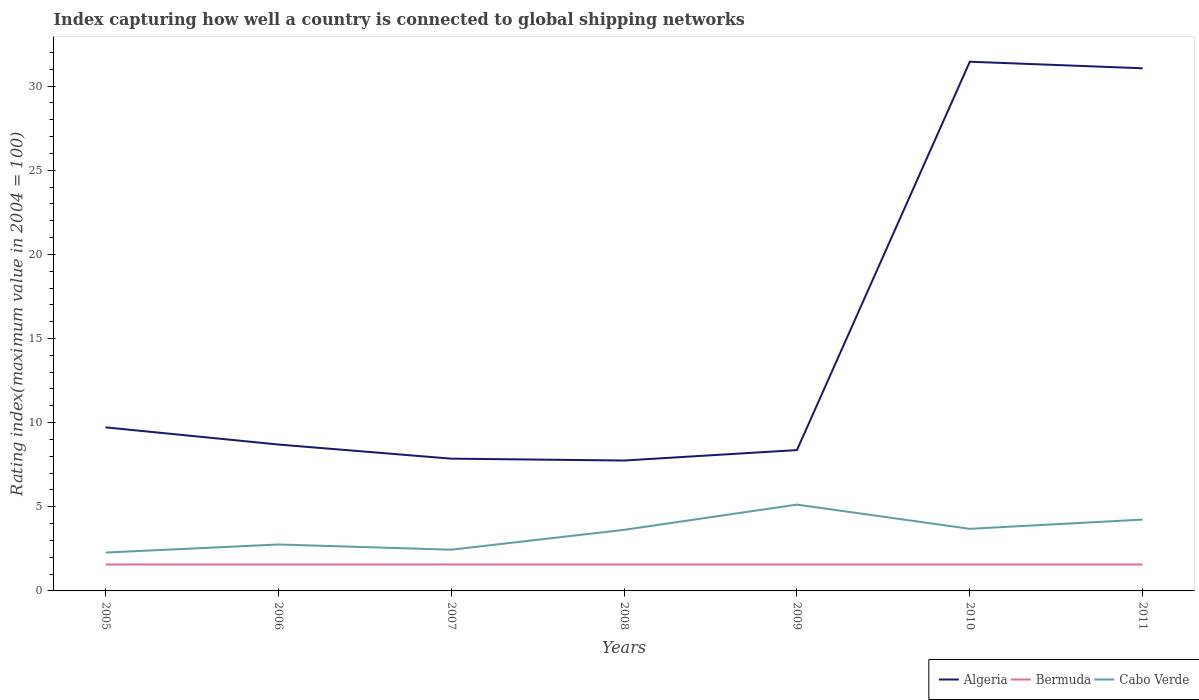How many different coloured lines are there?
Offer a terse response. 3. Does the line corresponding to Bermuda intersect with the line corresponding to Algeria?
Ensure brevity in your answer.  No. Is the number of lines equal to the number of legend labels?
Give a very brief answer. Yes. Across all years, what is the maximum rating index in Cabo Verde?
Give a very brief answer. 2.28. In which year was the rating index in Cabo Verde maximum?
Give a very brief answer. 2005. What is the total rating index in Bermuda in the graph?
Your answer should be very brief. 0. What is the difference between the highest and the second highest rating index in Algeria?
Provide a short and direct response. 23.7. How many lines are there?
Offer a terse response. 3. Are the values on the major ticks of Y-axis written in scientific E-notation?
Provide a succinct answer. No. Does the graph contain grids?
Provide a succinct answer. No. Where does the legend appear in the graph?
Offer a terse response. Bottom right. What is the title of the graph?
Provide a short and direct response. Index capturing how well a country is connected to global shipping networks. Does "Comoros" appear as one of the legend labels in the graph?
Keep it short and to the point. No. What is the label or title of the Y-axis?
Offer a very short reply. Rating index(maximum value in 2004 = 100). What is the Rating index(maximum value in 2004 = 100) in Algeria in 2005?
Keep it short and to the point. 9.72. What is the Rating index(maximum value in 2004 = 100) of Bermuda in 2005?
Your response must be concise. 1.57. What is the Rating index(maximum value in 2004 = 100) in Cabo Verde in 2005?
Make the answer very short. 2.28. What is the Rating index(maximum value in 2004 = 100) of Algeria in 2006?
Your response must be concise. 8.7. What is the Rating index(maximum value in 2004 = 100) in Bermuda in 2006?
Your answer should be compact. 1.57. What is the Rating index(maximum value in 2004 = 100) in Cabo Verde in 2006?
Your answer should be compact. 2.76. What is the Rating index(maximum value in 2004 = 100) in Algeria in 2007?
Offer a very short reply. 7.86. What is the Rating index(maximum value in 2004 = 100) in Bermuda in 2007?
Provide a short and direct response. 1.57. What is the Rating index(maximum value in 2004 = 100) in Cabo Verde in 2007?
Your answer should be compact. 2.45. What is the Rating index(maximum value in 2004 = 100) of Algeria in 2008?
Your answer should be compact. 7.75. What is the Rating index(maximum value in 2004 = 100) of Bermuda in 2008?
Offer a terse response. 1.57. What is the Rating index(maximum value in 2004 = 100) in Cabo Verde in 2008?
Keep it short and to the point. 3.63. What is the Rating index(maximum value in 2004 = 100) of Algeria in 2009?
Give a very brief answer. 8.37. What is the Rating index(maximum value in 2004 = 100) in Bermuda in 2009?
Offer a terse response. 1.57. What is the Rating index(maximum value in 2004 = 100) of Cabo Verde in 2009?
Make the answer very short. 5.13. What is the Rating index(maximum value in 2004 = 100) of Algeria in 2010?
Offer a very short reply. 31.45. What is the Rating index(maximum value in 2004 = 100) in Bermuda in 2010?
Make the answer very short. 1.57. What is the Rating index(maximum value in 2004 = 100) in Cabo Verde in 2010?
Keep it short and to the point. 3.69. What is the Rating index(maximum value in 2004 = 100) of Algeria in 2011?
Give a very brief answer. 31.06. What is the Rating index(maximum value in 2004 = 100) of Bermuda in 2011?
Offer a terse response. 1.57. What is the Rating index(maximum value in 2004 = 100) in Cabo Verde in 2011?
Make the answer very short. 4.24. Across all years, what is the maximum Rating index(maximum value in 2004 = 100) of Algeria?
Offer a very short reply. 31.45. Across all years, what is the maximum Rating index(maximum value in 2004 = 100) of Bermuda?
Offer a terse response. 1.57. Across all years, what is the maximum Rating index(maximum value in 2004 = 100) in Cabo Verde?
Ensure brevity in your answer.  5.13. Across all years, what is the minimum Rating index(maximum value in 2004 = 100) in Algeria?
Your response must be concise. 7.75. Across all years, what is the minimum Rating index(maximum value in 2004 = 100) in Bermuda?
Offer a very short reply. 1.57. Across all years, what is the minimum Rating index(maximum value in 2004 = 100) in Cabo Verde?
Your answer should be very brief. 2.28. What is the total Rating index(maximum value in 2004 = 100) in Algeria in the graph?
Keep it short and to the point. 104.91. What is the total Rating index(maximum value in 2004 = 100) in Bermuda in the graph?
Your response must be concise. 10.99. What is the total Rating index(maximum value in 2004 = 100) in Cabo Verde in the graph?
Your answer should be compact. 24.18. What is the difference between the Rating index(maximum value in 2004 = 100) of Cabo Verde in 2005 and that in 2006?
Offer a terse response. -0.48. What is the difference between the Rating index(maximum value in 2004 = 100) in Algeria in 2005 and that in 2007?
Offer a terse response. 1.86. What is the difference between the Rating index(maximum value in 2004 = 100) in Cabo Verde in 2005 and that in 2007?
Provide a succinct answer. -0.17. What is the difference between the Rating index(maximum value in 2004 = 100) in Algeria in 2005 and that in 2008?
Keep it short and to the point. 1.97. What is the difference between the Rating index(maximum value in 2004 = 100) in Cabo Verde in 2005 and that in 2008?
Your answer should be compact. -1.35. What is the difference between the Rating index(maximum value in 2004 = 100) in Algeria in 2005 and that in 2009?
Offer a terse response. 1.35. What is the difference between the Rating index(maximum value in 2004 = 100) of Cabo Verde in 2005 and that in 2009?
Keep it short and to the point. -2.85. What is the difference between the Rating index(maximum value in 2004 = 100) of Algeria in 2005 and that in 2010?
Offer a terse response. -21.73. What is the difference between the Rating index(maximum value in 2004 = 100) of Cabo Verde in 2005 and that in 2010?
Offer a very short reply. -1.41. What is the difference between the Rating index(maximum value in 2004 = 100) in Algeria in 2005 and that in 2011?
Your answer should be compact. -21.34. What is the difference between the Rating index(maximum value in 2004 = 100) of Bermuda in 2005 and that in 2011?
Give a very brief answer. 0. What is the difference between the Rating index(maximum value in 2004 = 100) of Cabo Verde in 2005 and that in 2011?
Your response must be concise. -1.96. What is the difference between the Rating index(maximum value in 2004 = 100) of Algeria in 2006 and that in 2007?
Keep it short and to the point. 0.84. What is the difference between the Rating index(maximum value in 2004 = 100) of Cabo Verde in 2006 and that in 2007?
Make the answer very short. 0.31. What is the difference between the Rating index(maximum value in 2004 = 100) in Bermuda in 2006 and that in 2008?
Your response must be concise. 0. What is the difference between the Rating index(maximum value in 2004 = 100) of Cabo Verde in 2006 and that in 2008?
Provide a succinct answer. -0.87. What is the difference between the Rating index(maximum value in 2004 = 100) of Algeria in 2006 and that in 2009?
Your response must be concise. 0.33. What is the difference between the Rating index(maximum value in 2004 = 100) of Bermuda in 2006 and that in 2009?
Offer a very short reply. 0. What is the difference between the Rating index(maximum value in 2004 = 100) of Cabo Verde in 2006 and that in 2009?
Offer a terse response. -2.37. What is the difference between the Rating index(maximum value in 2004 = 100) of Algeria in 2006 and that in 2010?
Offer a very short reply. -22.75. What is the difference between the Rating index(maximum value in 2004 = 100) in Bermuda in 2006 and that in 2010?
Ensure brevity in your answer.  0. What is the difference between the Rating index(maximum value in 2004 = 100) of Cabo Verde in 2006 and that in 2010?
Give a very brief answer. -0.93. What is the difference between the Rating index(maximum value in 2004 = 100) of Algeria in 2006 and that in 2011?
Make the answer very short. -22.36. What is the difference between the Rating index(maximum value in 2004 = 100) of Cabo Verde in 2006 and that in 2011?
Your answer should be compact. -1.48. What is the difference between the Rating index(maximum value in 2004 = 100) of Algeria in 2007 and that in 2008?
Make the answer very short. 0.11. What is the difference between the Rating index(maximum value in 2004 = 100) of Bermuda in 2007 and that in 2008?
Offer a very short reply. 0. What is the difference between the Rating index(maximum value in 2004 = 100) in Cabo Verde in 2007 and that in 2008?
Offer a terse response. -1.18. What is the difference between the Rating index(maximum value in 2004 = 100) in Algeria in 2007 and that in 2009?
Offer a terse response. -0.51. What is the difference between the Rating index(maximum value in 2004 = 100) in Cabo Verde in 2007 and that in 2009?
Provide a succinct answer. -2.68. What is the difference between the Rating index(maximum value in 2004 = 100) of Algeria in 2007 and that in 2010?
Provide a succinct answer. -23.59. What is the difference between the Rating index(maximum value in 2004 = 100) in Cabo Verde in 2007 and that in 2010?
Your response must be concise. -1.24. What is the difference between the Rating index(maximum value in 2004 = 100) of Algeria in 2007 and that in 2011?
Provide a short and direct response. -23.2. What is the difference between the Rating index(maximum value in 2004 = 100) of Cabo Verde in 2007 and that in 2011?
Keep it short and to the point. -1.79. What is the difference between the Rating index(maximum value in 2004 = 100) of Algeria in 2008 and that in 2009?
Your answer should be compact. -0.62. What is the difference between the Rating index(maximum value in 2004 = 100) in Bermuda in 2008 and that in 2009?
Your answer should be compact. 0. What is the difference between the Rating index(maximum value in 2004 = 100) of Algeria in 2008 and that in 2010?
Give a very brief answer. -23.7. What is the difference between the Rating index(maximum value in 2004 = 100) in Bermuda in 2008 and that in 2010?
Provide a succinct answer. 0. What is the difference between the Rating index(maximum value in 2004 = 100) of Cabo Verde in 2008 and that in 2010?
Offer a very short reply. -0.06. What is the difference between the Rating index(maximum value in 2004 = 100) in Algeria in 2008 and that in 2011?
Provide a succinct answer. -23.31. What is the difference between the Rating index(maximum value in 2004 = 100) in Cabo Verde in 2008 and that in 2011?
Offer a very short reply. -0.61. What is the difference between the Rating index(maximum value in 2004 = 100) of Algeria in 2009 and that in 2010?
Offer a terse response. -23.08. What is the difference between the Rating index(maximum value in 2004 = 100) in Cabo Verde in 2009 and that in 2010?
Your answer should be compact. 1.44. What is the difference between the Rating index(maximum value in 2004 = 100) of Algeria in 2009 and that in 2011?
Provide a short and direct response. -22.69. What is the difference between the Rating index(maximum value in 2004 = 100) of Bermuda in 2009 and that in 2011?
Provide a short and direct response. 0. What is the difference between the Rating index(maximum value in 2004 = 100) in Cabo Verde in 2009 and that in 2011?
Your answer should be very brief. 0.89. What is the difference between the Rating index(maximum value in 2004 = 100) of Algeria in 2010 and that in 2011?
Ensure brevity in your answer.  0.39. What is the difference between the Rating index(maximum value in 2004 = 100) of Cabo Verde in 2010 and that in 2011?
Give a very brief answer. -0.55. What is the difference between the Rating index(maximum value in 2004 = 100) in Algeria in 2005 and the Rating index(maximum value in 2004 = 100) in Bermuda in 2006?
Give a very brief answer. 8.15. What is the difference between the Rating index(maximum value in 2004 = 100) of Algeria in 2005 and the Rating index(maximum value in 2004 = 100) of Cabo Verde in 2006?
Provide a succinct answer. 6.96. What is the difference between the Rating index(maximum value in 2004 = 100) of Bermuda in 2005 and the Rating index(maximum value in 2004 = 100) of Cabo Verde in 2006?
Ensure brevity in your answer.  -1.19. What is the difference between the Rating index(maximum value in 2004 = 100) of Algeria in 2005 and the Rating index(maximum value in 2004 = 100) of Bermuda in 2007?
Give a very brief answer. 8.15. What is the difference between the Rating index(maximum value in 2004 = 100) in Algeria in 2005 and the Rating index(maximum value in 2004 = 100) in Cabo Verde in 2007?
Your answer should be very brief. 7.27. What is the difference between the Rating index(maximum value in 2004 = 100) in Bermuda in 2005 and the Rating index(maximum value in 2004 = 100) in Cabo Verde in 2007?
Your answer should be compact. -0.88. What is the difference between the Rating index(maximum value in 2004 = 100) of Algeria in 2005 and the Rating index(maximum value in 2004 = 100) of Bermuda in 2008?
Ensure brevity in your answer.  8.15. What is the difference between the Rating index(maximum value in 2004 = 100) of Algeria in 2005 and the Rating index(maximum value in 2004 = 100) of Cabo Verde in 2008?
Your answer should be compact. 6.09. What is the difference between the Rating index(maximum value in 2004 = 100) in Bermuda in 2005 and the Rating index(maximum value in 2004 = 100) in Cabo Verde in 2008?
Your answer should be very brief. -2.06. What is the difference between the Rating index(maximum value in 2004 = 100) of Algeria in 2005 and the Rating index(maximum value in 2004 = 100) of Bermuda in 2009?
Offer a terse response. 8.15. What is the difference between the Rating index(maximum value in 2004 = 100) in Algeria in 2005 and the Rating index(maximum value in 2004 = 100) in Cabo Verde in 2009?
Provide a succinct answer. 4.59. What is the difference between the Rating index(maximum value in 2004 = 100) of Bermuda in 2005 and the Rating index(maximum value in 2004 = 100) of Cabo Verde in 2009?
Your response must be concise. -3.56. What is the difference between the Rating index(maximum value in 2004 = 100) of Algeria in 2005 and the Rating index(maximum value in 2004 = 100) of Bermuda in 2010?
Your response must be concise. 8.15. What is the difference between the Rating index(maximum value in 2004 = 100) of Algeria in 2005 and the Rating index(maximum value in 2004 = 100) of Cabo Verde in 2010?
Provide a short and direct response. 6.03. What is the difference between the Rating index(maximum value in 2004 = 100) of Bermuda in 2005 and the Rating index(maximum value in 2004 = 100) of Cabo Verde in 2010?
Make the answer very short. -2.12. What is the difference between the Rating index(maximum value in 2004 = 100) in Algeria in 2005 and the Rating index(maximum value in 2004 = 100) in Bermuda in 2011?
Ensure brevity in your answer.  8.15. What is the difference between the Rating index(maximum value in 2004 = 100) of Algeria in 2005 and the Rating index(maximum value in 2004 = 100) of Cabo Verde in 2011?
Provide a short and direct response. 5.48. What is the difference between the Rating index(maximum value in 2004 = 100) of Bermuda in 2005 and the Rating index(maximum value in 2004 = 100) of Cabo Verde in 2011?
Provide a short and direct response. -2.67. What is the difference between the Rating index(maximum value in 2004 = 100) of Algeria in 2006 and the Rating index(maximum value in 2004 = 100) of Bermuda in 2007?
Provide a short and direct response. 7.13. What is the difference between the Rating index(maximum value in 2004 = 100) of Algeria in 2006 and the Rating index(maximum value in 2004 = 100) of Cabo Verde in 2007?
Provide a succinct answer. 6.25. What is the difference between the Rating index(maximum value in 2004 = 100) in Bermuda in 2006 and the Rating index(maximum value in 2004 = 100) in Cabo Verde in 2007?
Your answer should be compact. -0.88. What is the difference between the Rating index(maximum value in 2004 = 100) of Algeria in 2006 and the Rating index(maximum value in 2004 = 100) of Bermuda in 2008?
Your response must be concise. 7.13. What is the difference between the Rating index(maximum value in 2004 = 100) in Algeria in 2006 and the Rating index(maximum value in 2004 = 100) in Cabo Verde in 2008?
Your response must be concise. 5.07. What is the difference between the Rating index(maximum value in 2004 = 100) of Bermuda in 2006 and the Rating index(maximum value in 2004 = 100) of Cabo Verde in 2008?
Your answer should be very brief. -2.06. What is the difference between the Rating index(maximum value in 2004 = 100) of Algeria in 2006 and the Rating index(maximum value in 2004 = 100) of Bermuda in 2009?
Provide a succinct answer. 7.13. What is the difference between the Rating index(maximum value in 2004 = 100) of Algeria in 2006 and the Rating index(maximum value in 2004 = 100) of Cabo Verde in 2009?
Make the answer very short. 3.57. What is the difference between the Rating index(maximum value in 2004 = 100) in Bermuda in 2006 and the Rating index(maximum value in 2004 = 100) in Cabo Verde in 2009?
Your answer should be compact. -3.56. What is the difference between the Rating index(maximum value in 2004 = 100) in Algeria in 2006 and the Rating index(maximum value in 2004 = 100) in Bermuda in 2010?
Ensure brevity in your answer.  7.13. What is the difference between the Rating index(maximum value in 2004 = 100) in Algeria in 2006 and the Rating index(maximum value in 2004 = 100) in Cabo Verde in 2010?
Offer a very short reply. 5.01. What is the difference between the Rating index(maximum value in 2004 = 100) of Bermuda in 2006 and the Rating index(maximum value in 2004 = 100) of Cabo Verde in 2010?
Offer a very short reply. -2.12. What is the difference between the Rating index(maximum value in 2004 = 100) in Algeria in 2006 and the Rating index(maximum value in 2004 = 100) in Bermuda in 2011?
Provide a short and direct response. 7.13. What is the difference between the Rating index(maximum value in 2004 = 100) in Algeria in 2006 and the Rating index(maximum value in 2004 = 100) in Cabo Verde in 2011?
Offer a very short reply. 4.46. What is the difference between the Rating index(maximum value in 2004 = 100) in Bermuda in 2006 and the Rating index(maximum value in 2004 = 100) in Cabo Verde in 2011?
Provide a short and direct response. -2.67. What is the difference between the Rating index(maximum value in 2004 = 100) in Algeria in 2007 and the Rating index(maximum value in 2004 = 100) in Bermuda in 2008?
Offer a terse response. 6.29. What is the difference between the Rating index(maximum value in 2004 = 100) of Algeria in 2007 and the Rating index(maximum value in 2004 = 100) of Cabo Verde in 2008?
Make the answer very short. 4.23. What is the difference between the Rating index(maximum value in 2004 = 100) of Bermuda in 2007 and the Rating index(maximum value in 2004 = 100) of Cabo Verde in 2008?
Your answer should be very brief. -2.06. What is the difference between the Rating index(maximum value in 2004 = 100) in Algeria in 2007 and the Rating index(maximum value in 2004 = 100) in Bermuda in 2009?
Offer a very short reply. 6.29. What is the difference between the Rating index(maximum value in 2004 = 100) of Algeria in 2007 and the Rating index(maximum value in 2004 = 100) of Cabo Verde in 2009?
Ensure brevity in your answer.  2.73. What is the difference between the Rating index(maximum value in 2004 = 100) in Bermuda in 2007 and the Rating index(maximum value in 2004 = 100) in Cabo Verde in 2009?
Give a very brief answer. -3.56. What is the difference between the Rating index(maximum value in 2004 = 100) of Algeria in 2007 and the Rating index(maximum value in 2004 = 100) of Bermuda in 2010?
Keep it short and to the point. 6.29. What is the difference between the Rating index(maximum value in 2004 = 100) of Algeria in 2007 and the Rating index(maximum value in 2004 = 100) of Cabo Verde in 2010?
Your answer should be compact. 4.17. What is the difference between the Rating index(maximum value in 2004 = 100) in Bermuda in 2007 and the Rating index(maximum value in 2004 = 100) in Cabo Verde in 2010?
Your answer should be very brief. -2.12. What is the difference between the Rating index(maximum value in 2004 = 100) of Algeria in 2007 and the Rating index(maximum value in 2004 = 100) of Bermuda in 2011?
Your answer should be very brief. 6.29. What is the difference between the Rating index(maximum value in 2004 = 100) of Algeria in 2007 and the Rating index(maximum value in 2004 = 100) of Cabo Verde in 2011?
Provide a short and direct response. 3.62. What is the difference between the Rating index(maximum value in 2004 = 100) of Bermuda in 2007 and the Rating index(maximum value in 2004 = 100) of Cabo Verde in 2011?
Your answer should be compact. -2.67. What is the difference between the Rating index(maximum value in 2004 = 100) of Algeria in 2008 and the Rating index(maximum value in 2004 = 100) of Bermuda in 2009?
Make the answer very short. 6.18. What is the difference between the Rating index(maximum value in 2004 = 100) in Algeria in 2008 and the Rating index(maximum value in 2004 = 100) in Cabo Verde in 2009?
Provide a succinct answer. 2.62. What is the difference between the Rating index(maximum value in 2004 = 100) of Bermuda in 2008 and the Rating index(maximum value in 2004 = 100) of Cabo Verde in 2009?
Your answer should be very brief. -3.56. What is the difference between the Rating index(maximum value in 2004 = 100) in Algeria in 2008 and the Rating index(maximum value in 2004 = 100) in Bermuda in 2010?
Offer a terse response. 6.18. What is the difference between the Rating index(maximum value in 2004 = 100) in Algeria in 2008 and the Rating index(maximum value in 2004 = 100) in Cabo Verde in 2010?
Offer a very short reply. 4.06. What is the difference between the Rating index(maximum value in 2004 = 100) of Bermuda in 2008 and the Rating index(maximum value in 2004 = 100) of Cabo Verde in 2010?
Your answer should be very brief. -2.12. What is the difference between the Rating index(maximum value in 2004 = 100) in Algeria in 2008 and the Rating index(maximum value in 2004 = 100) in Bermuda in 2011?
Your response must be concise. 6.18. What is the difference between the Rating index(maximum value in 2004 = 100) in Algeria in 2008 and the Rating index(maximum value in 2004 = 100) in Cabo Verde in 2011?
Ensure brevity in your answer.  3.51. What is the difference between the Rating index(maximum value in 2004 = 100) in Bermuda in 2008 and the Rating index(maximum value in 2004 = 100) in Cabo Verde in 2011?
Provide a short and direct response. -2.67. What is the difference between the Rating index(maximum value in 2004 = 100) in Algeria in 2009 and the Rating index(maximum value in 2004 = 100) in Cabo Verde in 2010?
Your answer should be very brief. 4.68. What is the difference between the Rating index(maximum value in 2004 = 100) of Bermuda in 2009 and the Rating index(maximum value in 2004 = 100) of Cabo Verde in 2010?
Provide a succinct answer. -2.12. What is the difference between the Rating index(maximum value in 2004 = 100) of Algeria in 2009 and the Rating index(maximum value in 2004 = 100) of Bermuda in 2011?
Your answer should be compact. 6.8. What is the difference between the Rating index(maximum value in 2004 = 100) in Algeria in 2009 and the Rating index(maximum value in 2004 = 100) in Cabo Verde in 2011?
Your response must be concise. 4.13. What is the difference between the Rating index(maximum value in 2004 = 100) in Bermuda in 2009 and the Rating index(maximum value in 2004 = 100) in Cabo Verde in 2011?
Ensure brevity in your answer.  -2.67. What is the difference between the Rating index(maximum value in 2004 = 100) of Algeria in 2010 and the Rating index(maximum value in 2004 = 100) of Bermuda in 2011?
Provide a succinct answer. 29.88. What is the difference between the Rating index(maximum value in 2004 = 100) in Algeria in 2010 and the Rating index(maximum value in 2004 = 100) in Cabo Verde in 2011?
Keep it short and to the point. 27.21. What is the difference between the Rating index(maximum value in 2004 = 100) of Bermuda in 2010 and the Rating index(maximum value in 2004 = 100) of Cabo Verde in 2011?
Provide a short and direct response. -2.67. What is the average Rating index(maximum value in 2004 = 100) of Algeria per year?
Your response must be concise. 14.99. What is the average Rating index(maximum value in 2004 = 100) of Bermuda per year?
Give a very brief answer. 1.57. What is the average Rating index(maximum value in 2004 = 100) of Cabo Verde per year?
Your answer should be compact. 3.45. In the year 2005, what is the difference between the Rating index(maximum value in 2004 = 100) of Algeria and Rating index(maximum value in 2004 = 100) of Bermuda?
Your answer should be very brief. 8.15. In the year 2005, what is the difference between the Rating index(maximum value in 2004 = 100) in Algeria and Rating index(maximum value in 2004 = 100) in Cabo Verde?
Offer a terse response. 7.44. In the year 2005, what is the difference between the Rating index(maximum value in 2004 = 100) in Bermuda and Rating index(maximum value in 2004 = 100) in Cabo Verde?
Make the answer very short. -0.71. In the year 2006, what is the difference between the Rating index(maximum value in 2004 = 100) of Algeria and Rating index(maximum value in 2004 = 100) of Bermuda?
Make the answer very short. 7.13. In the year 2006, what is the difference between the Rating index(maximum value in 2004 = 100) in Algeria and Rating index(maximum value in 2004 = 100) in Cabo Verde?
Offer a terse response. 5.94. In the year 2006, what is the difference between the Rating index(maximum value in 2004 = 100) of Bermuda and Rating index(maximum value in 2004 = 100) of Cabo Verde?
Give a very brief answer. -1.19. In the year 2007, what is the difference between the Rating index(maximum value in 2004 = 100) of Algeria and Rating index(maximum value in 2004 = 100) of Bermuda?
Provide a succinct answer. 6.29. In the year 2007, what is the difference between the Rating index(maximum value in 2004 = 100) in Algeria and Rating index(maximum value in 2004 = 100) in Cabo Verde?
Keep it short and to the point. 5.41. In the year 2007, what is the difference between the Rating index(maximum value in 2004 = 100) of Bermuda and Rating index(maximum value in 2004 = 100) of Cabo Verde?
Your answer should be very brief. -0.88. In the year 2008, what is the difference between the Rating index(maximum value in 2004 = 100) in Algeria and Rating index(maximum value in 2004 = 100) in Bermuda?
Keep it short and to the point. 6.18. In the year 2008, what is the difference between the Rating index(maximum value in 2004 = 100) in Algeria and Rating index(maximum value in 2004 = 100) in Cabo Verde?
Provide a short and direct response. 4.12. In the year 2008, what is the difference between the Rating index(maximum value in 2004 = 100) of Bermuda and Rating index(maximum value in 2004 = 100) of Cabo Verde?
Your response must be concise. -2.06. In the year 2009, what is the difference between the Rating index(maximum value in 2004 = 100) of Algeria and Rating index(maximum value in 2004 = 100) of Cabo Verde?
Provide a short and direct response. 3.24. In the year 2009, what is the difference between the Rating index(maximum value in 2004 = 100) in Bermuda and Rating index(maximum value in 2004 = 100) in Cabo Verde?
Give a very brief answer. -3.56. In the year 2010, what is the difference between the Rating index(maximum value in 2004 = 100) of Algeria and Rating index(maximum value in 2004 = 100) of Bermuda?
Your answer should be compact. 29.88. In the year 2010, what is the difference between the Rating index(maximum value in 2004 = 100) of Algeria and Rating index(maximum value in 2004 = 100) of Cabo Verde?
Offer a very short reply. 27.76. In the year 2010, what is the difference between the Rating index(maximum value in 2004 = 100) of Bermuda and Rating index(maximum value in 2004 = 100) of Cabo Verde?
Your response must be concise. -2.12. In the year 2011, what is the difference between the Rating index(maximum value in 2004 = 100) in Algeria and Rating index(maximum value in 2004 = 100) in Bermuda?
Provide a succinct answer. 29.49. In the year 2011, what is the difference between the Rating index(maximum value in 2004 = 100) of Algeria and Rating index(maximum value in 2004 = 100) of Cabo Verde?
Offer a terse response. 26.82. In the year 2011, what is the difference between the Rating index(maximum value in 2004 = 100) of Bermuda and Rating index(maximum value in 2004 = 100) of Cabo Verde?
Your answer should be compact. -2.67. What is the ratio of the Rating index(maximum value in 2004 = 100) of Algeria in 2005 to that in 2006?
Ensure brevity in your answer.  1.12. What is the ratio of the Rating index(maximum value in 2004 = 100) in Bermuda in 2005 to that in 2006?
Your answer should be compact. 1. What is the ratio of the Rating index(maximum value in 2004 = 100) of Cabo Verde in 2005 to that in 2006?
Provide a succinct answer. 0.83. What is the ratio of the Rating index(maximum value in 2004 = 100) of Algeria in 2005 to that in 2007?
Provide a short and direct response. 1.24. What is the ratio of the Rating index(maximum value in 2004 = 100) of Cabo Verde in 2005 to that in 2007?
Give a very brief answer. 0.93. What is the ratio of the Rating index(maximum value in 2004 = 100) of Algeria in 2005 to that in 2008?
Offer a terse response. 1.25. What is the ratio of the Rating index(maximum value in 2004 = 100) of Bermuda in 2005 to that in 2008?
Make the answer very short. 1. What is the ratio of the Rating index(maximum value in 2004 = 100) in Cabo Verde in 2005 to that in 2008?
Your response must be concise. 0.63. What is the ratio of the Rating index(maximum value in 2004 = 100) of Algeria in 2005 to that in 2009?
Give a very brief answer. 1.16. What is the ratio of the Rating index(maximum value in 2004 = 100) of Cabo Verde in 2005 to that in 2009?
Provide a succinct answer. 0.44. What is the ratio of the Rating index(maximum value in 2004 = 100) of Algeria in 2005 to that in 2010?
Keep it short and to the point. 0.31. What is the ratio of the Rating index(maximum value in 2004 = 100) in Cabo Verde in 2005 to that in 2010?
Give a very brief answer. 0.62. What is the ratio of the Rating index(maximum value in 2004 = 100) in Algeria in 2005 to that in 2011?
Provide a succinct answer. 0.31. What is the ratio of the Rating index(maximum value in 2004 = 100) in Cabo Verde in 2005 to that in 2011?
Ensure brevity in your answer.  0.54. What is the ratio of the Rating index(maximum value in 2004 = 100) of Algeria in 2006 to that in 2007?
Ensure brevity in your answer.  1.11. What is the ratio of the Rating index(maximum value in 2004 = 100) in Bermuda in 2006 to that in 2007?
Offer a very short reply. 1. What is the ratio of the Rating index(maximum value in 2004 = 100) of Cabo Verde in 2006 to that in 2007?
Provide a short and direct response. 1.13. What is the ratio of the Rating index(maximum value in 2004 = 100) of Algeria in 2006 to that in 2008?
Your answer should be compact. 1.12. What is the ratio of the Rating index(maximum value in 2004 = 100) of Cabo Verde in 2006 to that in 2008?
Make the answer very short. 0.76. What is the ratio of the Rating index(maximum value in 2004 = 100) in Algeria in 2006 to that in 2009?
Your answer should be compact. 1.04. What is the ratio of the Rating index(maximum value in 2004 = 100) of Cabo Verde in 2006 to that in 2009?
Your response must be concise. 0.54. What is the ratio of the Rating index(maximum value in 2004 = 100) in Algeria in 2006 to that in 2010?
Provide a succinct answer. 0.28. What is the ratio of the Rating index(maximum value in 2004 = 100) of Cabo Verde in 2006 to that in 2010?
Provide a short and direct response. 0.75. What is the ratio of the Rating index(maximum value in 2004 = 100) of Algeria in 2006 to that in 2011?
Keep it short and to the point. 0.28. What is the ratio of the Rating index(maximum value in 2004 = 100) of Bermuda in 2006 to that in 2011?
Your response must be concise. 1. What is the ratio of the Rating index(maximum value in 2004 = 100) in Cabo Verde in 2006 to that in 2011?
Ensure brevity in your answer.  0.65. What is the ratio of the Rating index(maximum value in 2004 = 100) of Algeria in 2007 to that in 2008?
Offer a very short reply. 1.01. What is the ratio of the Rating index(maximum value in 2004 = 100) of Cabo Verde in 2007 to that in 2008?
Provide a succinct answer. 0.67. What is the ratio of the Rating index(maximum value in 2004 = 100) in Algeria in 2007 to that in 2009?
Provide a succinct answer. 0.94. What is the ratio of the Rating index(maximum value in 2004 = 100) in Bermuda in 2007 to that in 2009?
Offer a very short reply. 1. What is the ratio of the Rating index(maximum value in 2004 = 100) in Cabo Verde in 2007 to that in 2009?
Your answer should be compact. 0.48. What is the ratio of the Rating index(maximum value in 2004 = 100) in Algeria in 2007 to that in 2010?
Your response must be concise. 0.25. What is the ratio of the Rating index(maximum value in 2004 = 100) of Cabo Verde in 2007 to that in 2010?
Your answer should be very brief. 0.66. What is the ratio of the Rating index(maximum value in 2004 = 100) in Algeria in 2007 to that in 2011?
Provide a short and direct response. 0.25. What is the ratio of the Rating index(maximum value in 2004 = 100) in Cabo Verde in 2007 to that in 2011?
Your answer should be very brief. 0.58. What is the ratio of the Rating index(maximum value in 2004 = 100) in Algeria in 2008 to that in 2009?
Provide a short and direct response. 0.93. What is the ratio of the Rating index(maximum value in 2004 = 100) of Bermuda in 2008 to that in 2009?
Give a very brief answer. 1. What is the ratio of the Rating index(maximum value in 2004 = 100) of Cabo Verde in 2008 to that in 2009?
Make the answer very short. 0.71. What is the ratio of the Rating index(maximum value in 2004 = 100) of Algeria in 2008 to that in 2010?
Offer a very short reply. 0.25. What is the ratio of the Rating index(maximum value in 2004 = 100) in Cabo Verde in 2008 to that in 2010?
Make the answer very short. 0.98. What is the ratio of the Rating index(maximum value in 2004 = 100) in Algeria in 2008 to that in 2011?
Your answer should be compact. 0.25. What is the ratio of the Rating index(maximum value in 2004 = 100) of Cabo Verde in 2008 to that in 2011?
Offer a very short reply. 0.86. What is the ratio of the Rating index(maximum value in 2004 = 100) of Algeria in 2009 to that in 2010?
Keep it short and to the point. 0.27. What is the ratio of the Rating index(maximum value in 2004 = 100) in Bermuda in 2009 to that in 2010?
Make the answer very short. 1. What is the ratio of the Rating index(maximum value in 2004 = 100) of Cabo Verde in 2009 to that in 2010?
Your answer should be compact. 1.39. What is the ratio of the Rating index(maximum value in 2004 = 100) in Algeria in 2009 to that in 2011?
Make the answer very short. 0.27. What is the ratio of the Rating index(maximum value in 2004 = 100) in Bermuda in 2009 to that in 2011?
Make the answer very short. 1. What is the ratio of the Rating index(maximum value in 2004 = 100) in Cabo Verde in 2009 to that in 2011?
Offer a very short reply. 1.21. What is the ratio of the Rating index(maximum value in 2004 = 100) of Algeria in 2010 to that in 2011?
Your answer should be very brief. 1.01. What is the ratio of the Rating index(maximum value in 2004 = 100) of Cabo Verde in 2010 to that in 2011?
Your response must be concise. 0.87. What is the difference between the highest and the second highest Rating index(maximum value in 2004 = 100) in Algeria?
Offer a terse response. 0.39. What is the difference between the highest and the second highest Rating index(maximum value in 2004 = 100) in Bermuda?
Keep it short and to the point. 0. What is the difference between the highest and the second highest Rating index(maximum value in 2004 = 100) of Cabo Verde?
Offer a very short reply. 0.89. What is the difference between the highest and the lowest Rating index(maximum value in 2004 = 100) of Algeria?
Give a very brief answer. 23.7. What is the difference between the highest and the lowest Rating index(maximum value in 2004 = 100) of Cabo Verde?
Your answer should be very brief. 2.85. 